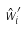Convert formula to latex. <formula><loc_0><loc_0><loc_500><loc_500>\hat { w } _ { i } ^ { \prime }</formula> 